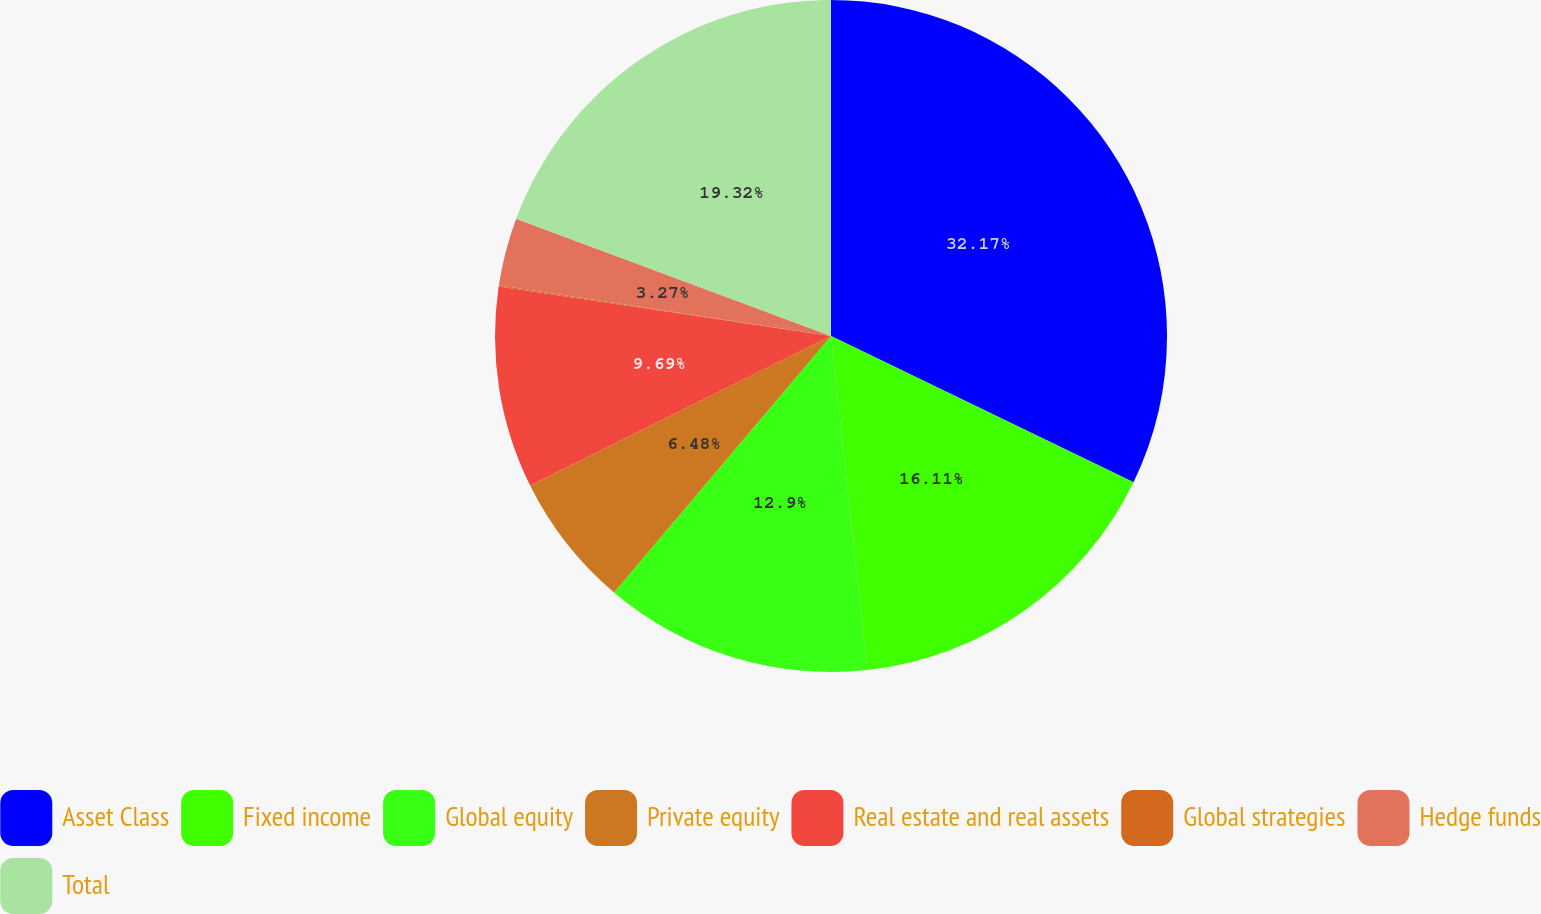Convert chart to OTSL. <chart><loc_0><loc_0><loc_500><loc_500><pie_chart><fcel>Asset Class<fcel>Fixed income<fcel>Global equity<fcel>Private equity<fcel>Real estate and real assets<fcel>Global strategies<fcel>Hedge funds<fcel>Total<nl><fcel>32.16%<fcel>16.11%<fcel>12.9%<fcel>6.48%<fcel>9.69%<fcel>0.06%<fcel>3.27%<fcel>19.32%<nl></chart> 